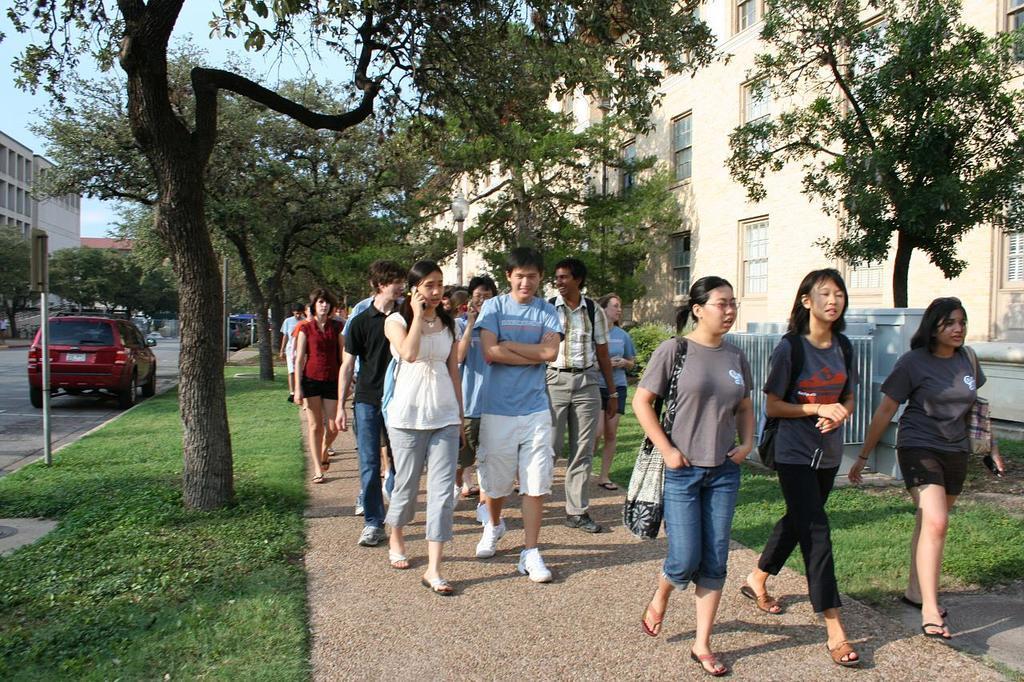Can you describe this image briefly? In this picture we can see group of people, they are walking on the pathway, beside to them we can see few trees and buildings, and also we can find few vehicles on the road. 